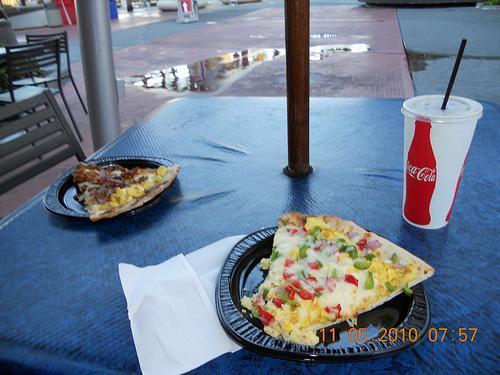How many plates are there?
Give a very brief answer. 2. How many chairs are behind the pole?
Give a very brief answer. 2. 